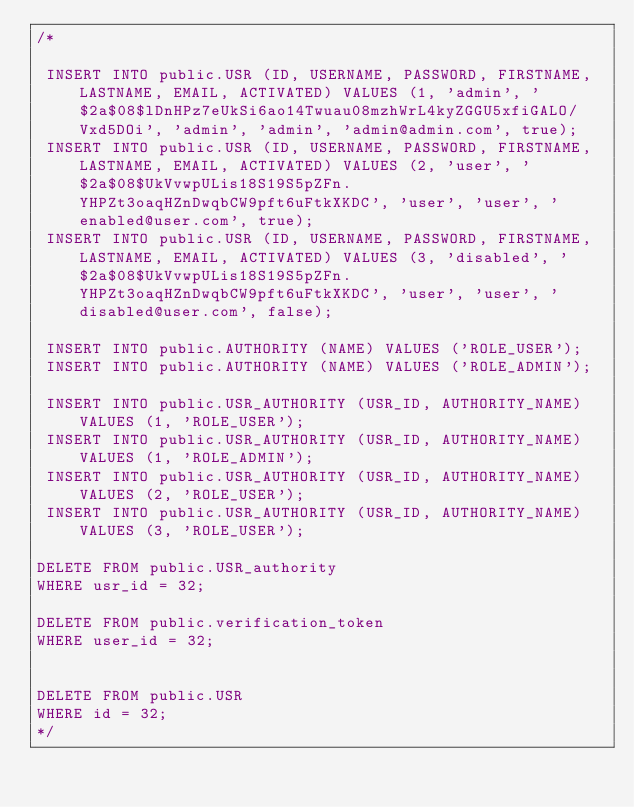Convert code to text. <code><loc_0><loc_0><loc_500><loc_500><_SQL_>/*

 INSERT INTO public.USR (ID, USERNAME, PASSWORD, FIRSTNAME, LASTNAME, EMAIL, ACTIVATED) VALUES (1, 'admin', '$2a$08$lDnHPz7eUkSi6ao14Twuau08mzhWrL4kyZGGU5xfiGALO/Vxd5DOi', 'admin', 'admin', 'admin@admin.com', true);
 INSERT INTO public.USR (ID, USERNAME, PASSWORD, FIRSTNAME, LASTNAME, EMAIL, ACTIVATED) VALUES (2, 'user', '$2a$08$UkVvwpULis18S19S5pZFn.YHPZt3oaqHZnDwqbCW9pft6uFtkXKDC', 'user', 'user', 'enabled@user.com', true);
 INSERT INTO public.USR (ID, USERNAME, PASSWORD, FIRSTNAME, LASTNAME, EMAIL, ACTIVATED) VALUES (3, 'disabled', '$2a$08$UkVvwpULis18S19S5pZFn.YHPZt3oaqHZnDwqbCW9pft6uFtkXKDC', 'user', 'user', 'disabled@user.com', false);

 INSERT INTO public.AUTHORITY (NAME) VALUES ('ROLE_USER');
 INSERT INTO public.AUTHORITY (NAME) VALUES ('ROLE_ADMIN');

 INSERT INTO public.USR_AUTHORITY (USR_ID, AUTHORITY_NAME) VALUES (1, 'ROLE_USER');
 INSERT INTO public.USR_AUTHORITY (USR_ID, AUTHORITY_NAME) VALUES (1, 'ROLE_ADMIN');
 INSERT INTO public.USR_AUTHORITY (USR_ID, AUTHORITY_NAME) VALUES (2, 'ROLE_USER');
 INSERT INTO public.USR_AUTHORITY (USR_ID, AUTHORITY_NAME) VALUES (3, 'ROLE_USER');

DELETE FROM public.USR_authority
WHERE usr_id = 32;

DELETE FROM public.verification_token
WHERE user_id = 32;


DELETE FROM public.USR
WHERE id = 32;
*/
</code> 